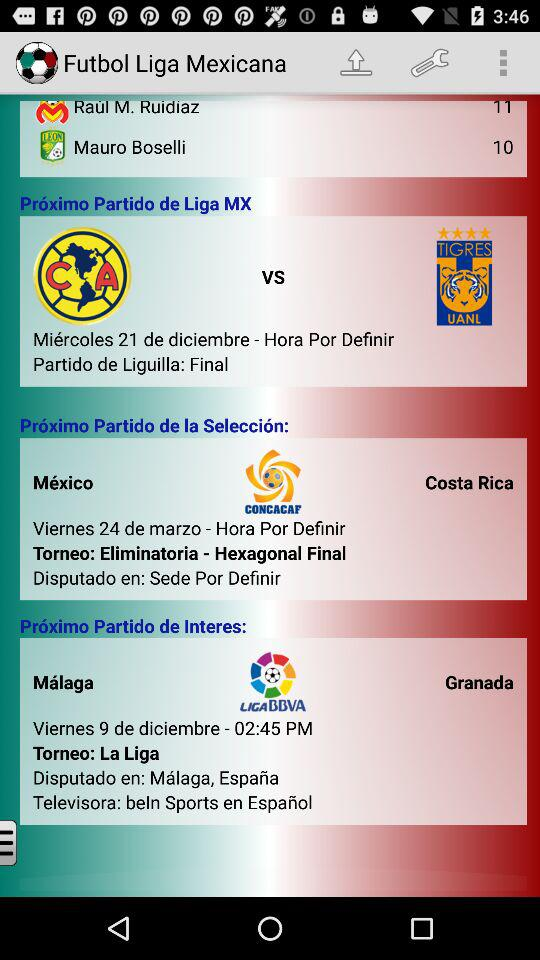How many more goals does Raul M. Ruidiaz have than Mauro Boselli?
Answer the question using a single word or phrase. 1 